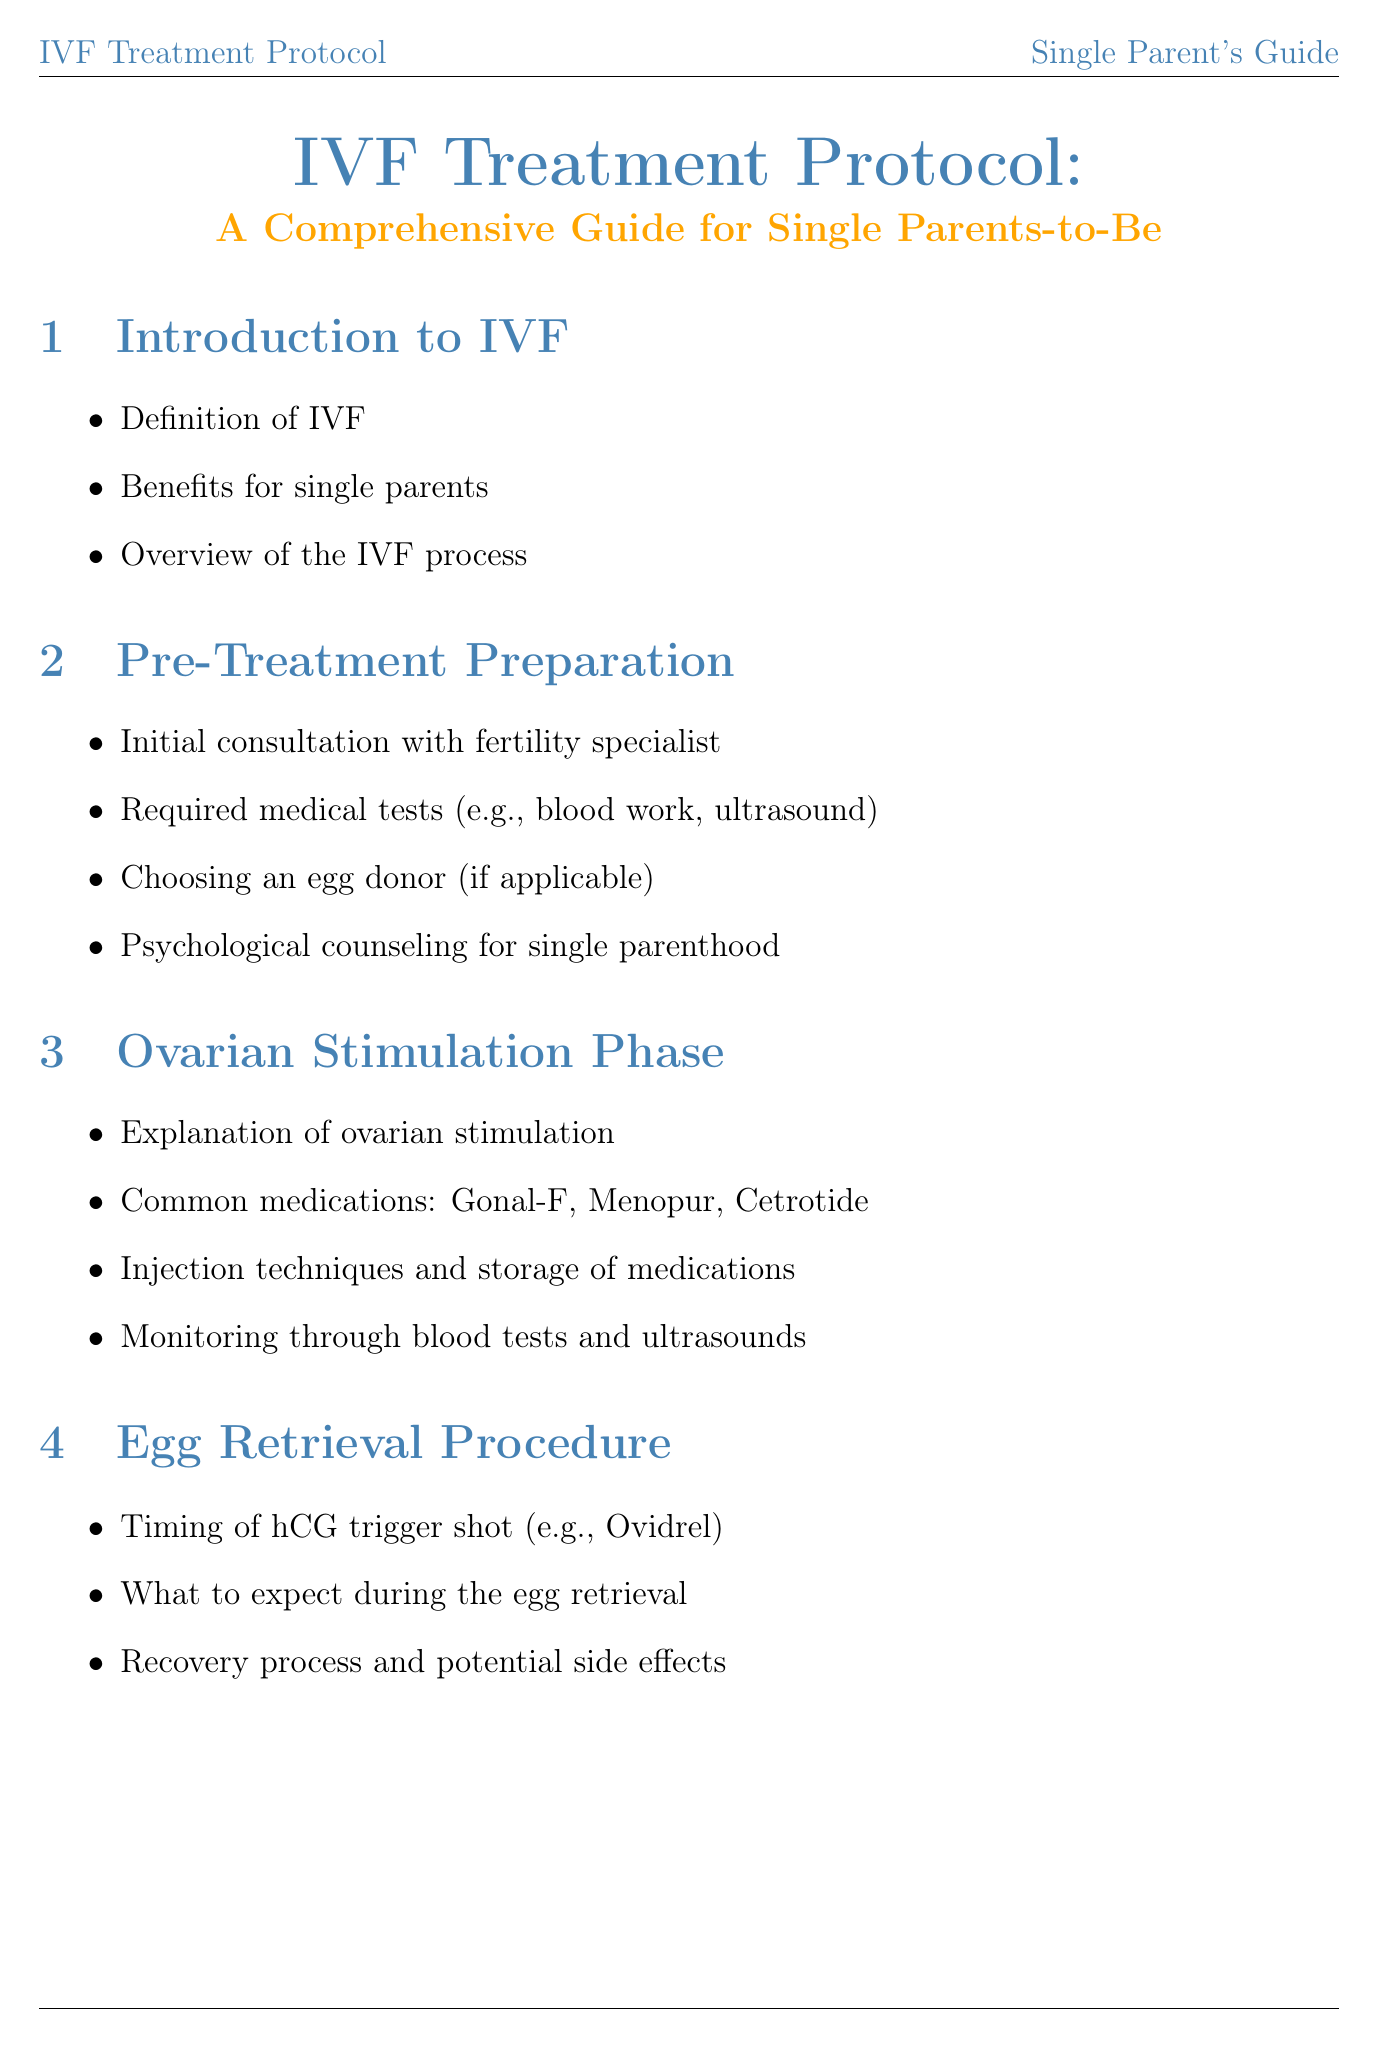What is the title of the manual? The title of the manual is stated clearly at the beginning.
Answer: IVF Treatment Protocol: A Comprehensive Guide for Single Parents-to-Be What medication is used for ovarian stimulation on Day 1? The document outlines the medications used for ovarian stimulation specifically.
Answer: Gonal-F and Menopur What is the recommended dose for Cetrotide? The document specifies the dose for each medication, including Cetrotide.
Answer: 0.25 mg What should you expect during the egg retrieval? This section covers the experiences and expectations during the procedure.
Answer: What to expect during the egg retrieval How many times is Estrace administered during luteal support? The document provides a detailed medication schedule, including administration frequency.
Answer: Twice daily What is one benefit of IVF for single parents? The introduction highlights various advantages of IVF for single parents.
Answer: Benefits for single parents What are the emotional support resources mentioned? The document lists coping strategies and resources for emotional support specifically for single parents.
Answer: Support groups and online communities What does the trigger shot medication name? The specific medication used for the trigger shot is announced in relation to the IVF process.
Answer: Ovidrel What type of injection technique is used for Gonal-F? The manual explains the injection techniques for various medications including Gonal-F.
Answer: Subcutaneous 